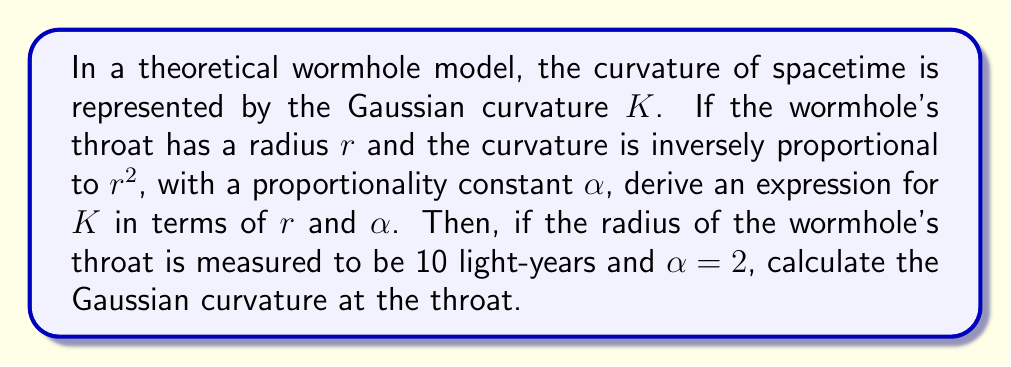Teach me how to tackle this problem. Let's approach this problem step-by-step:

1) We are told that the Gaussian curvature $K$ is inversely proportional to $r^2$. This can be expressed mathematically as:

   $$K \propto \frac{1}{r^2}$$

2) To convert this proportionality into an equation, we introduce the proportionality constant $\alpha$:

   $$K = \frac{\alpha}{r^2}$$

3) This is our general expression for the Gaussian curvature of the wormhole's throat in terms of $r$ and $\alpha$.

4) Now, we're given specific values to work with:
   - Radius of the wormhole's throat, $r = 10$ light-years
   - Proportionality constant, $\alpha = 2$

5) To calculate the Gaussian curvature, we simply substitute these values into our equation:

   $$K = \frac{2}{(10)^2} = \frac{2}{100} = 0.02$$

6) The units of $K$ will be the inverse square of the units of $r$. Since $r$ is in light-years, $K$ will be in (light-years)$^{-2}$.

This result suggests that the spacetime at the throat of this theoretical wormhole has a positive curvature, which is consistent with the idea that wormholes represent "shortcuts" through spacetime, effectively bringing distant points closer together.
Answer: The Gaussian curvature at the wormhole's throat is $K = 0.02$ (light-years)$^{-2}$. 